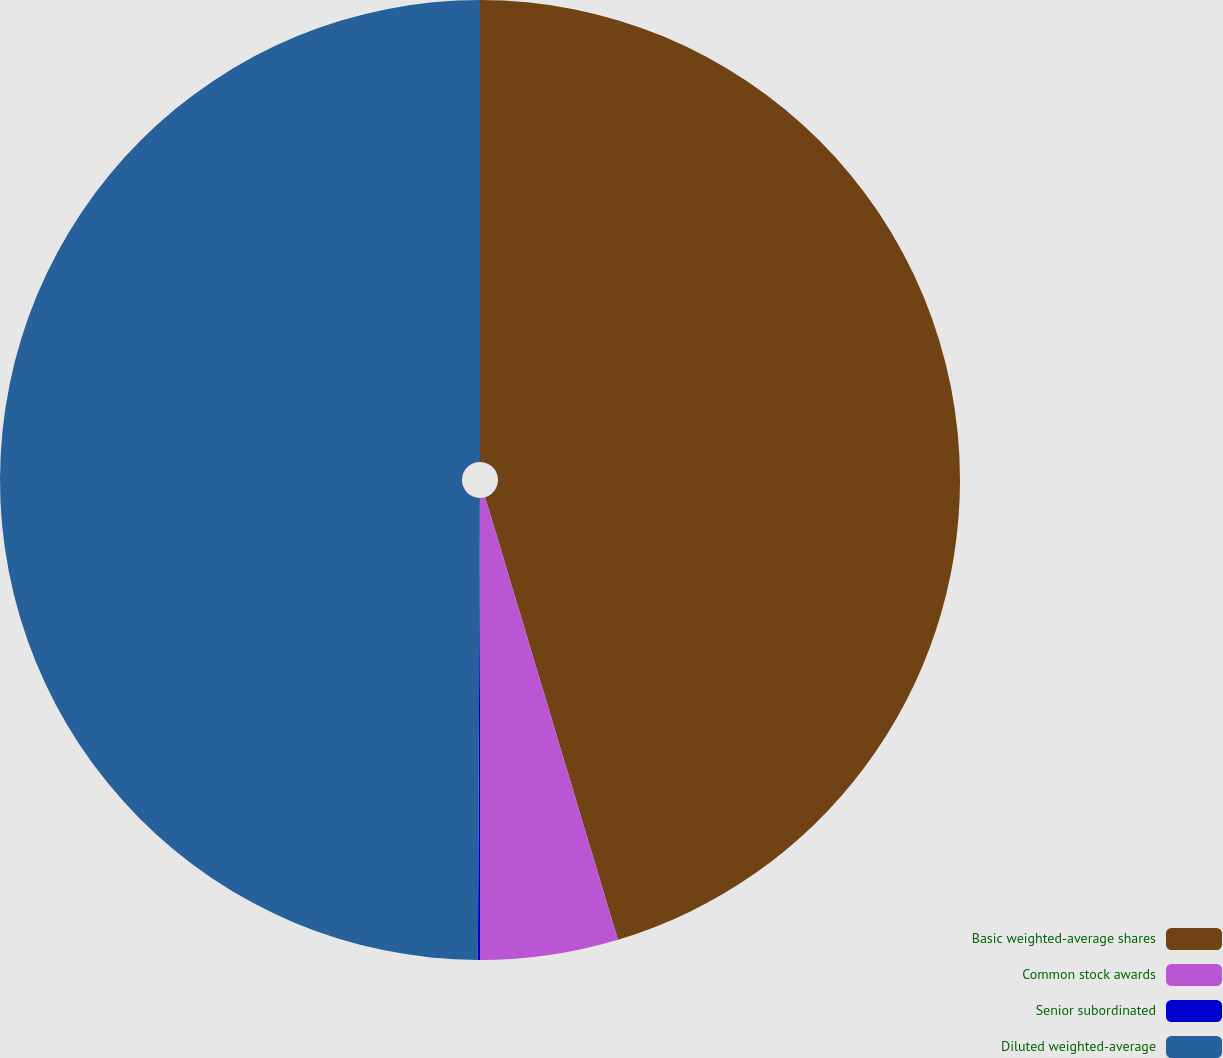Convert chart. <chart><loc_0><loc_0><loc_500><loc_500><pie_chart><fcel>Basic weighted-average shares<fcel>Common stock awards<fcel>Senior subordinated<fcel>Diluted weighted-average<nl><fcel>45.36%<fcel>4.64%<fcel>0.07%<fcel>49.93%<nl></chart> 